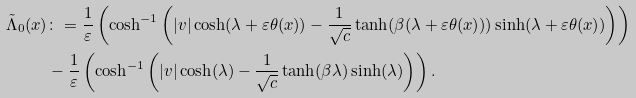Convert formula to latex. <formula><loc_0><loc_0><loc_500><loc_500>\tilde { \Lambda } _ { 0 } ( x ) & \colon = \frac { 1 } { \varepsilon } \left ( \cosh ^ { - 1 } \left ( | v | \cosh ( \lambda + \varepsilon \theta ( x ) ) - \frac { 1 } { \sqrt { c } } \tanh ( \beta ( \lambda + \varepsilon \theta ( x ) ) ) \sinh ( \lambda + \varepsilon \theta ( x ) ) \right ) \right ) \\ & - \frac { 1 } { \varepsilon } \left ( \cosh ^ { - 1 } \left ( | v | \cosh ( \lambda ) - \frac { 1 } { \sqrt { c } } \tanh ( \beta \lambda ) \sinh ( \lambda ) \right ) \right ) .</formula> 